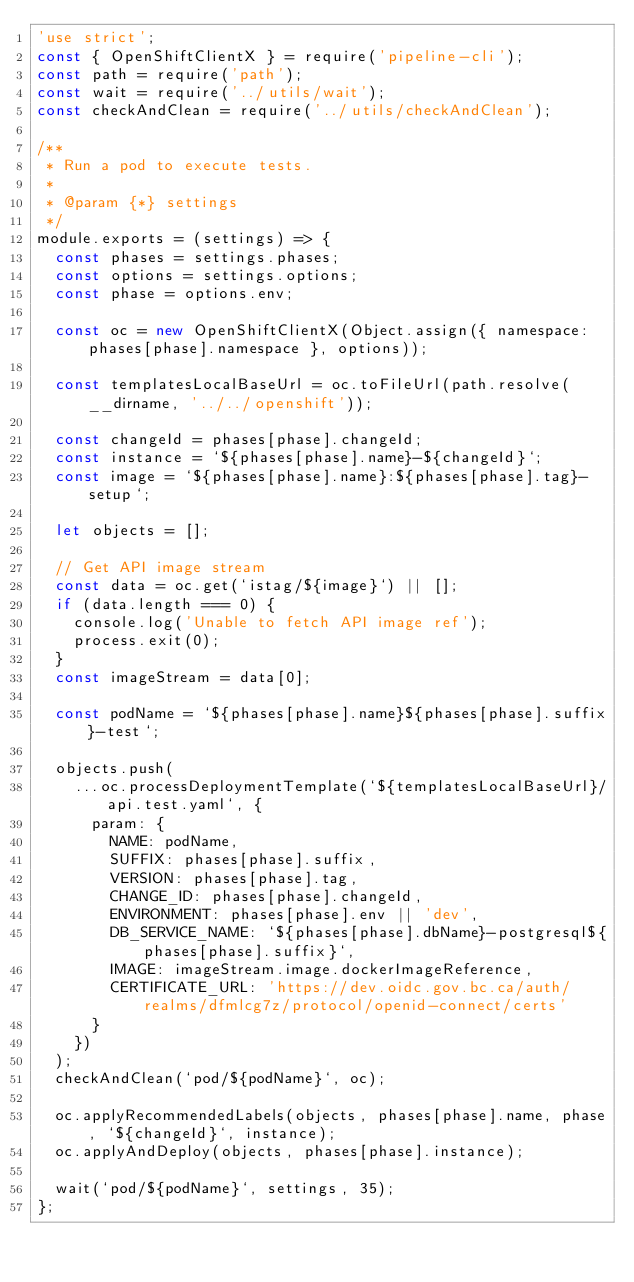<code> <loc_0><loc_0><loc_500><loc_500><_JavaScript_>'use strict';
const { OpenShiftClientX } = require('pipeline-cli');
const path = require('path');
const wait = require('../utils/wait');
const checkAndClean = require('../utils/checkAndClean');

/**
 * Run a pod to execute tests.
 *
 * @param {*} settings
 */
module.exports = (settings) => {
  const phases = settings.phases;
  const options = settings.options;
  const phase = options.env;

  const oc = new OpenShiftClientX(Object.assign({ namespace: phases[phase].namespace }, options));

  const templatesLocalBaseUrl = oc.toFileUrl(path.resolve(__dirname, '../../openshift'));

  const changeId = phases[phase].changeId;
  const instance = `${phases[phase].name}-${changeId}`;
  const image = `${phases[phase].name}:${phases[phase].tag}-setup`;

  let objects = [];

  // Get API image stream
  const data = oc.get(`istag/${image}`) || [];
  if (data.length === 0) {
    console.log('Unable to fetch API image ref');
    process.exit(0);
  }
  const imageStream = data[0];

  const podName = `${phases[phase].name}${phases[phase].suffix}-test`;

  objects.push(
    ...oc.processDeploymentTemplate(`${templatesLocalBaseUrl}/api.test.yaml`, {
      param: {
        NAME: podName,
        SUFFIX: phases[phase].suffix,
        VERSION: phases[phase].tag,
        CHANGE_ID: phases[phase].changeId,
        ENVIRONMENT: phases[phase].env || 'dev',
        DB_SERVICE_NAME: `${phases[phase].dbName}-postgresql${phases[phase].suffix}`,
        IMAGE: imageStream.image.dockerImageReference,
        CERTIFICATE_URL: 'https://dev.oidc.gov.bc.ca/auth/realms/dfmlcg7z/protocol/openid-connect/certs'
      }
    })
  );
  checkAndClean(`pod/${podName}`, oc);

  oc.applyRecommendedLabels(objects, phases[phase].name, phase, `${changeId}`, instance);
  oc.applyAndDeploy(objects, phases[phase].instance);

  wait(`pod/${podName}`, settings, 35);
};
</code> 